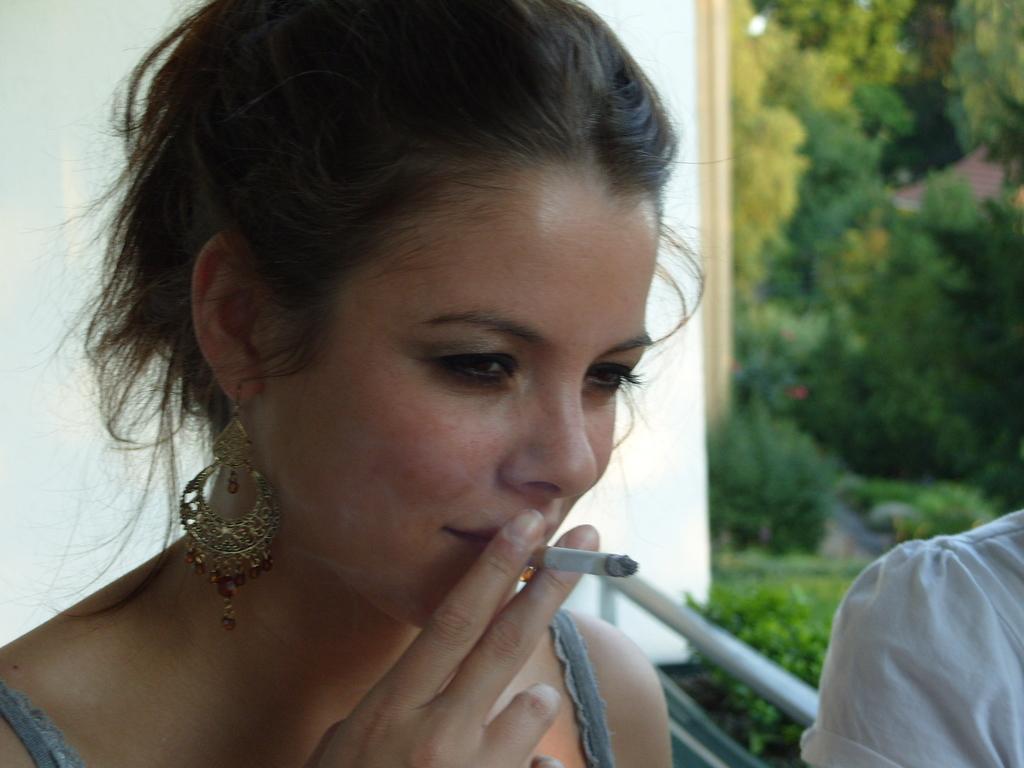Could you give a brief overview of what you see in this image? In this image we can see a lady smoking a cigarette. In the background of the image there is wall. There are trees. To the left side of the image there is a person. 